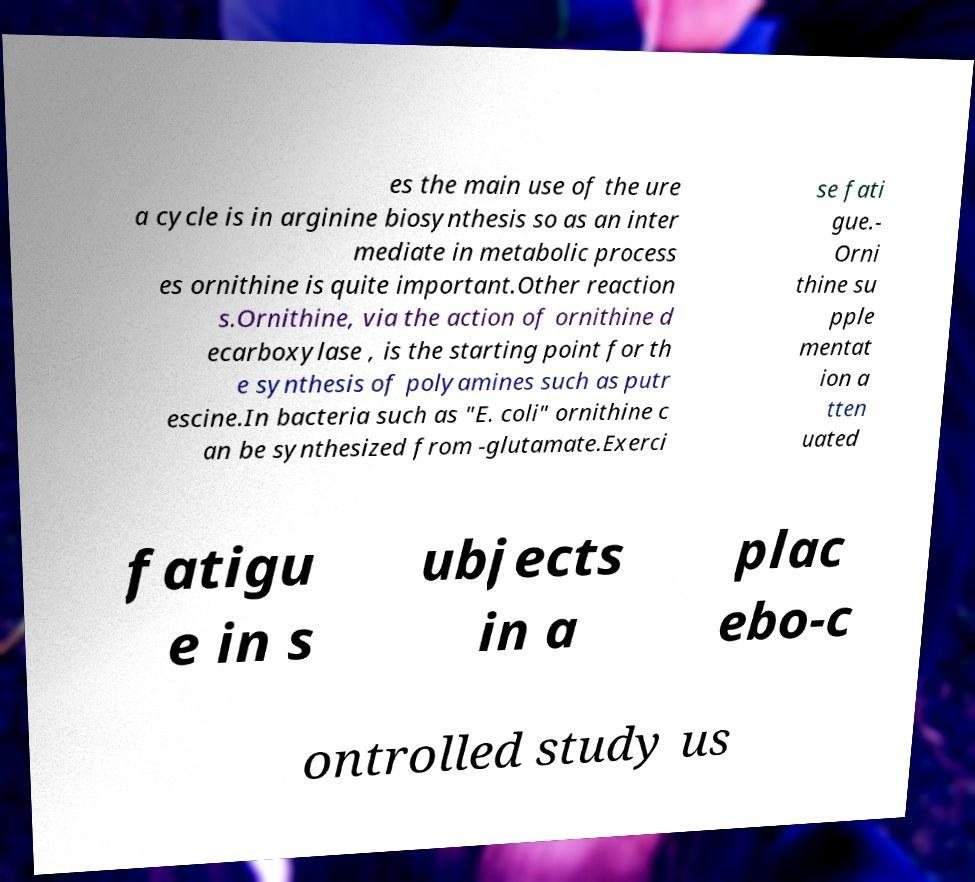Could you extract and type out the text from this image? es the main use of the ure a cycle is in arginine biosynthesis so as an inter mediate in metabolic process es ornithine is quite important.Other reaction s.Ornithine, via the action of ornithine d ecarboxylase , is the starting point for th e synthesis of polyamines such as putr escine.In bacteria such as "E. coli" ornithine c an be synthesized from -glutamate.Exerci se fati gue.- Orni thine su pple mentat ion a tten uated fatigu e in s ubjects in a plac ebo-c ontrolled study us 